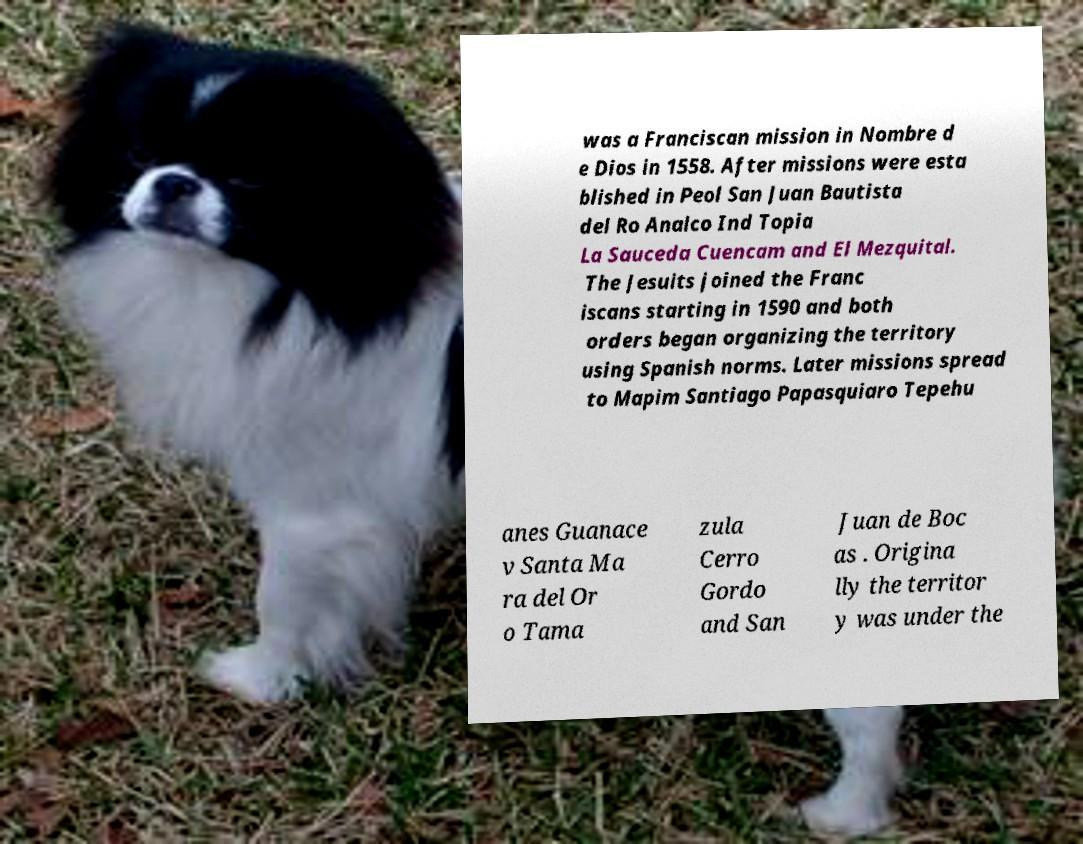Could you assist in decoding the text presented in this image and type it out clearly? was a Franciscan mission in Nombre d e Dios in 1558. After missions were esta blished in Peol San Juan Bautista del Ro Analco Ind Topia La Sauceda Cuencam and El Mezquital. The Jesuits joined the Franc iscans starting in 1590 and both orders began organizing the territory using Spanish norms. Later missions spread to Mapim Santiago Papasquiaro Tepehu anes Guanace v Santa Ma ra del Or o Tama zula Cerro Gordo and San Juan de Boc as . Origina lly the territor y was under the 